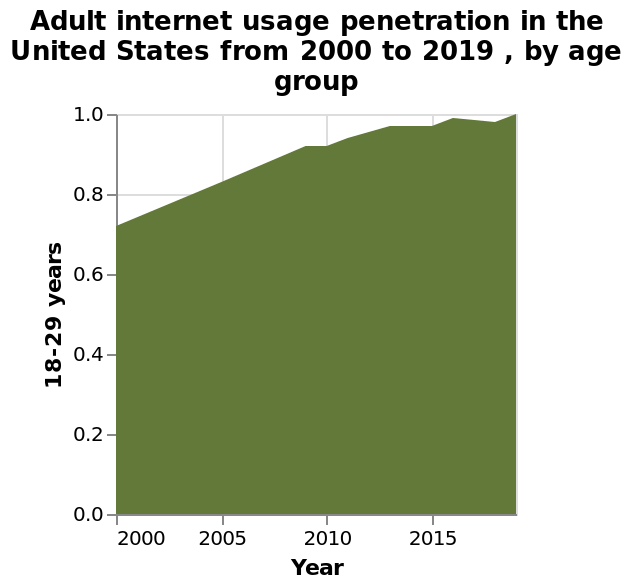<image>
What does the y-axis represent on the area graph?  The y-axis represents adult internet usage penetration, measured on a scale from 0.0 to 1.0. What is the maximum value on the y-axis? The maximum value on the y-axis is 1.0. 